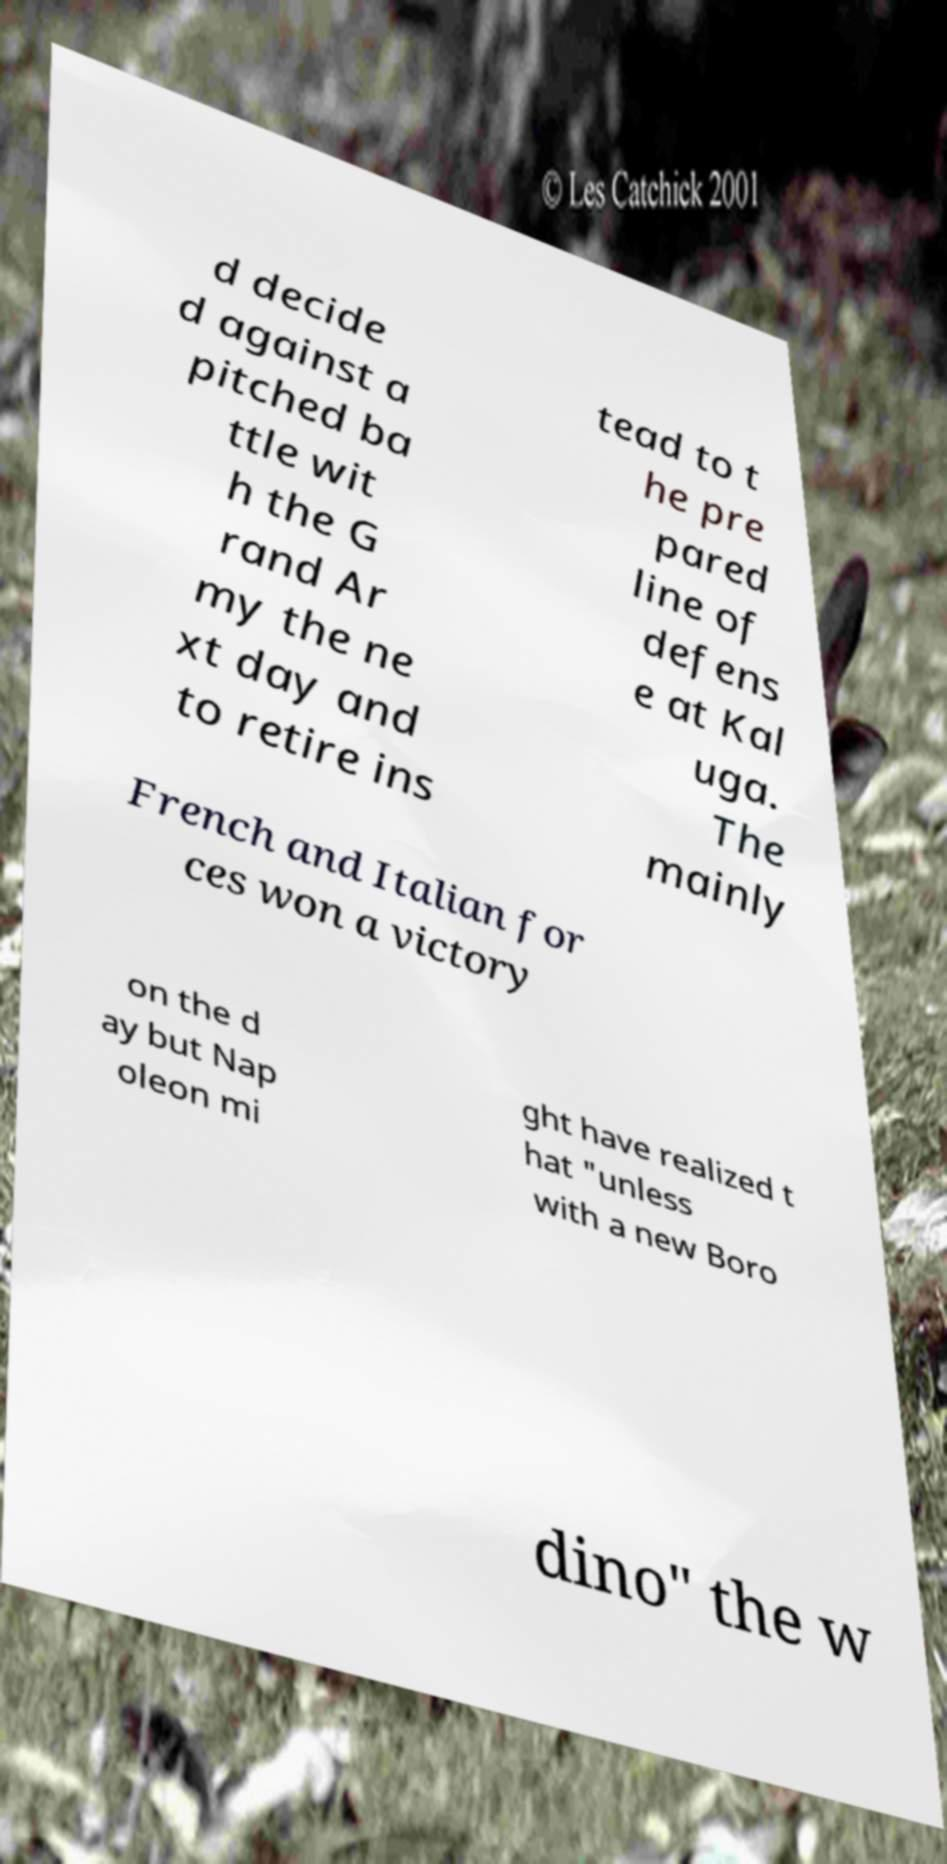For documentation purposes, I need the text within this image transcribed. Could you provide that? d decide d against a pitched ba ttle wit h the G rand Ar my the ne xt day and to retire ins tead to t he pre pared line of defens e at Kal uga. The mainly French and Italian for ces won a victory on the d ay but Nap oleon mi ght have realized t hat "unless with a new Boro dino" the w 